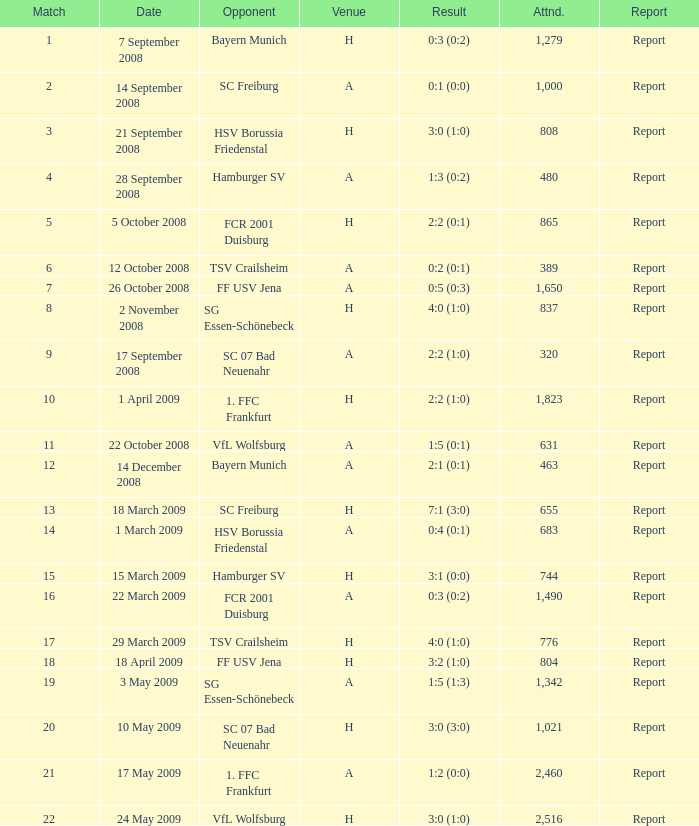Which match had more than 1,490 people in attendance to watch FCR 2001 Duisburg have a result of 0:3 (0:2)? None. 